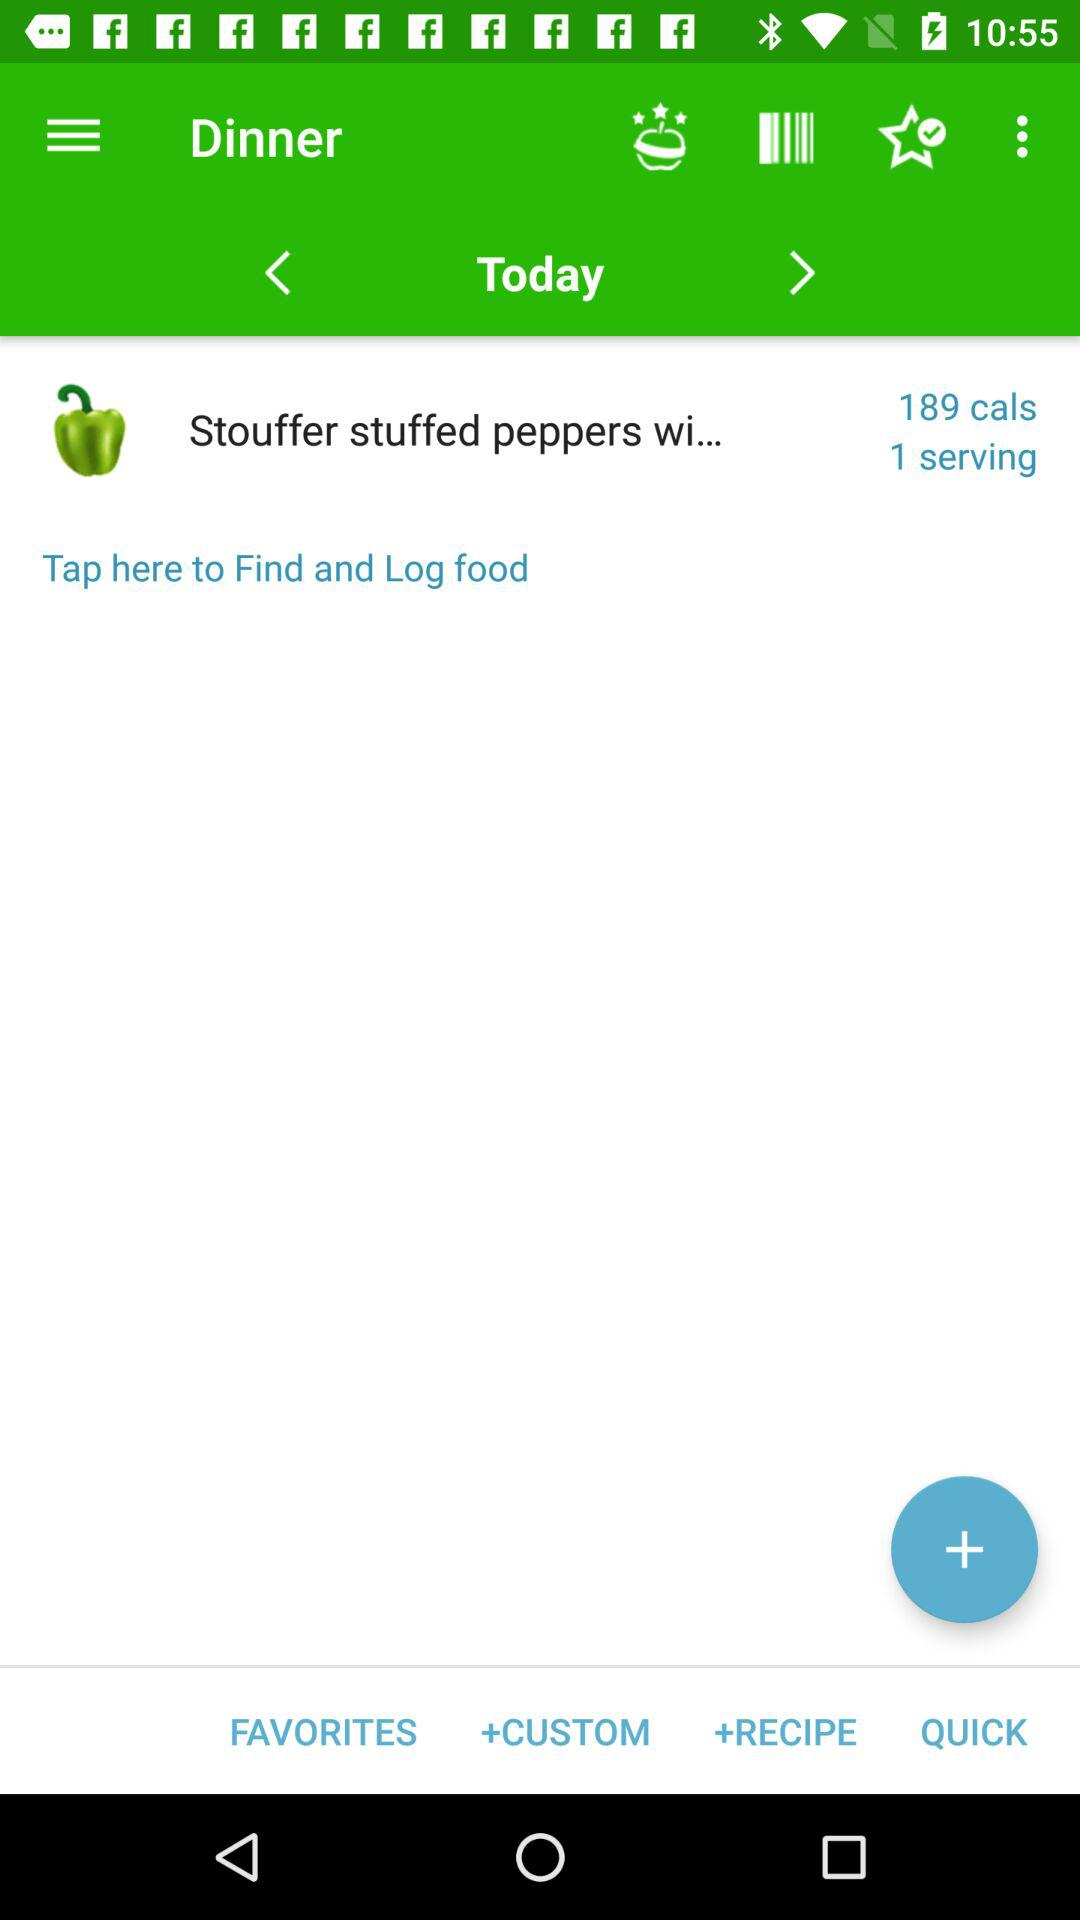How many servings are there that contain 189 calories? There is 1 serving. 